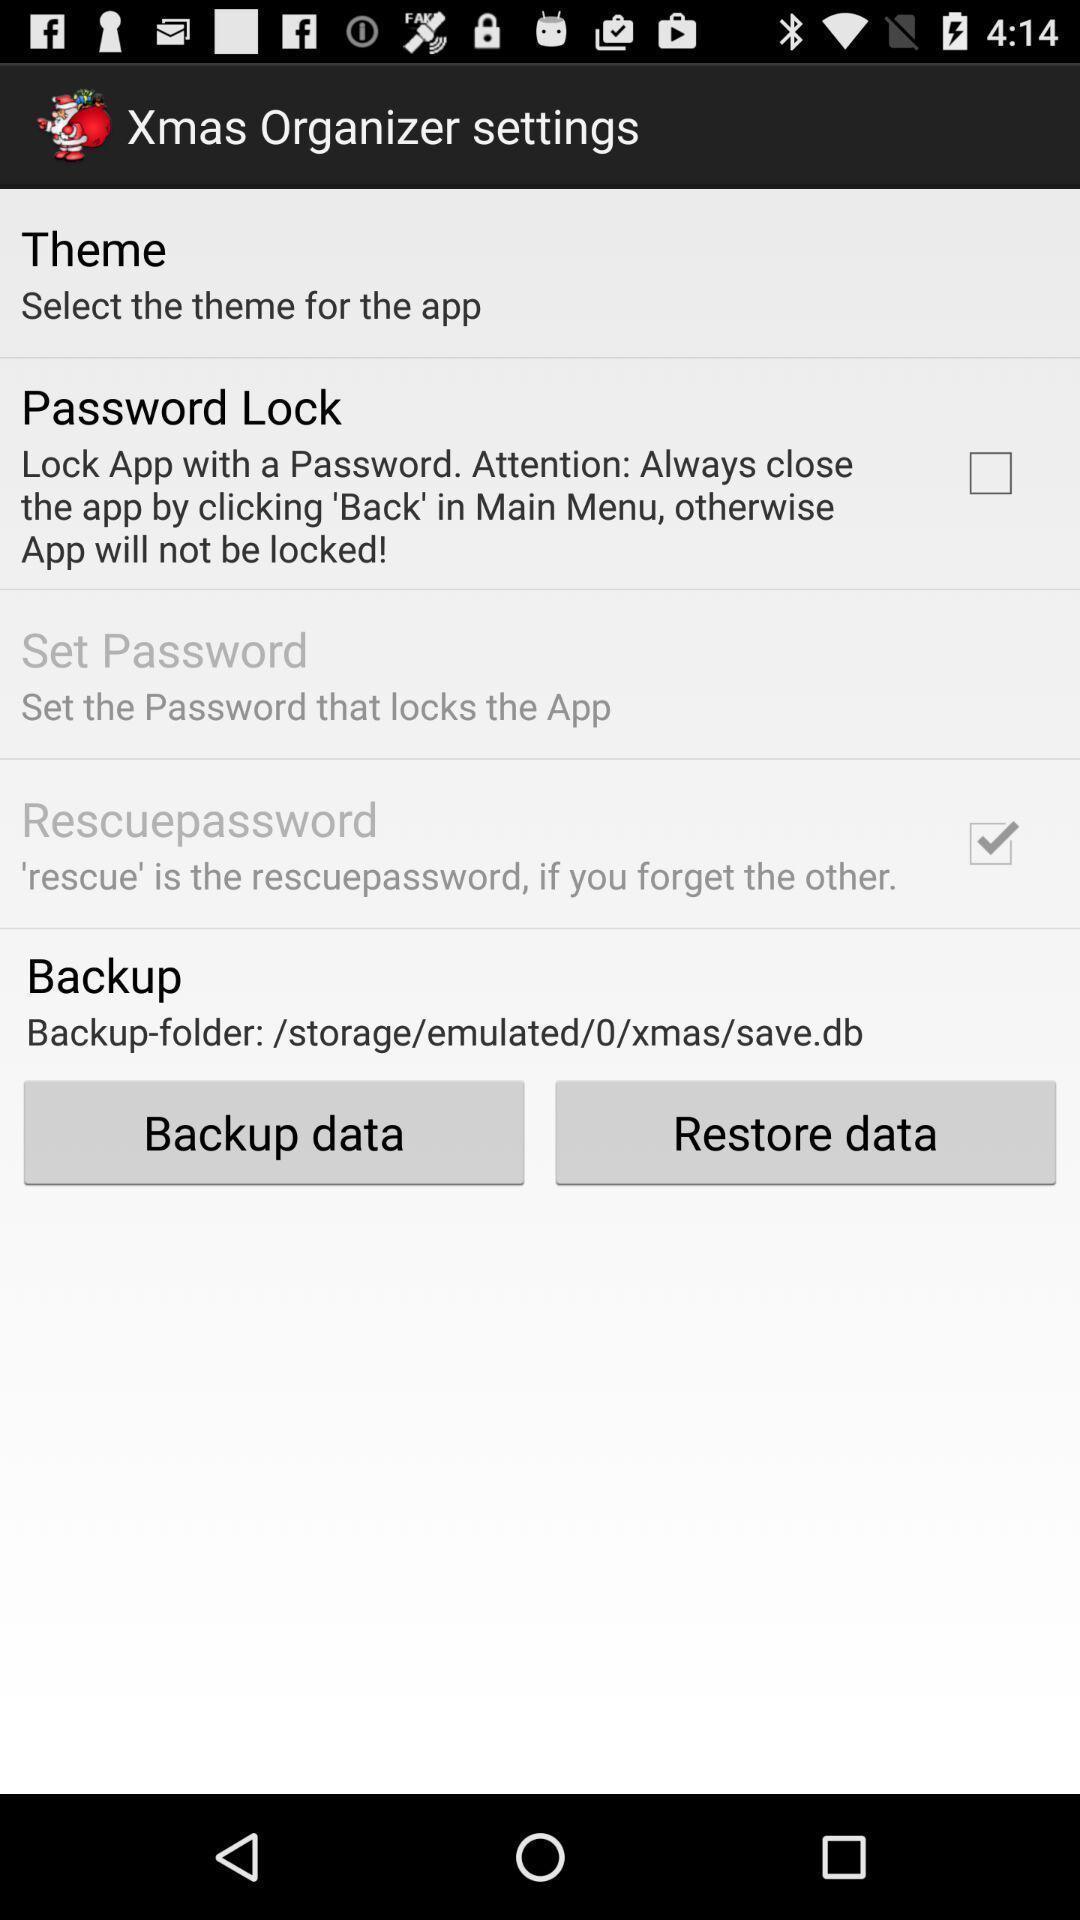Provide a textual representation of this image. Settings page. 